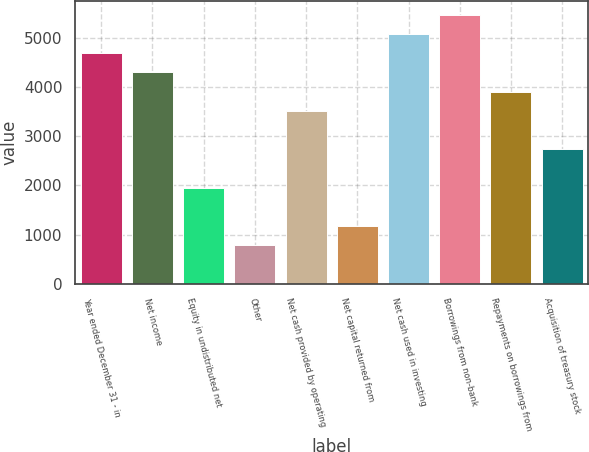<chart> <loc_0><loc_0><loc_500><loc_500><bar_chart><fcel>Year ended December 31 - in<fcel>Net income<fcel>Equity in undistributed net<fcel>Other<fcel>Net cash provided by operating<fcel>Net capital returned from<fcel>Net cash used in investing<fcel>Borrowings from non-bank<fcel>Repayments on borrowings from<fcel>Acquisition of treasury stock<nl><fcel>4691.6<fcel>4300.8<fcel>1956<fcel>783.6<fcel>3519.2<fcel>1174.4<fcel>5082.4<fcel>5473.2<fcel>3910<fcel>2737.6<nl></chart> 